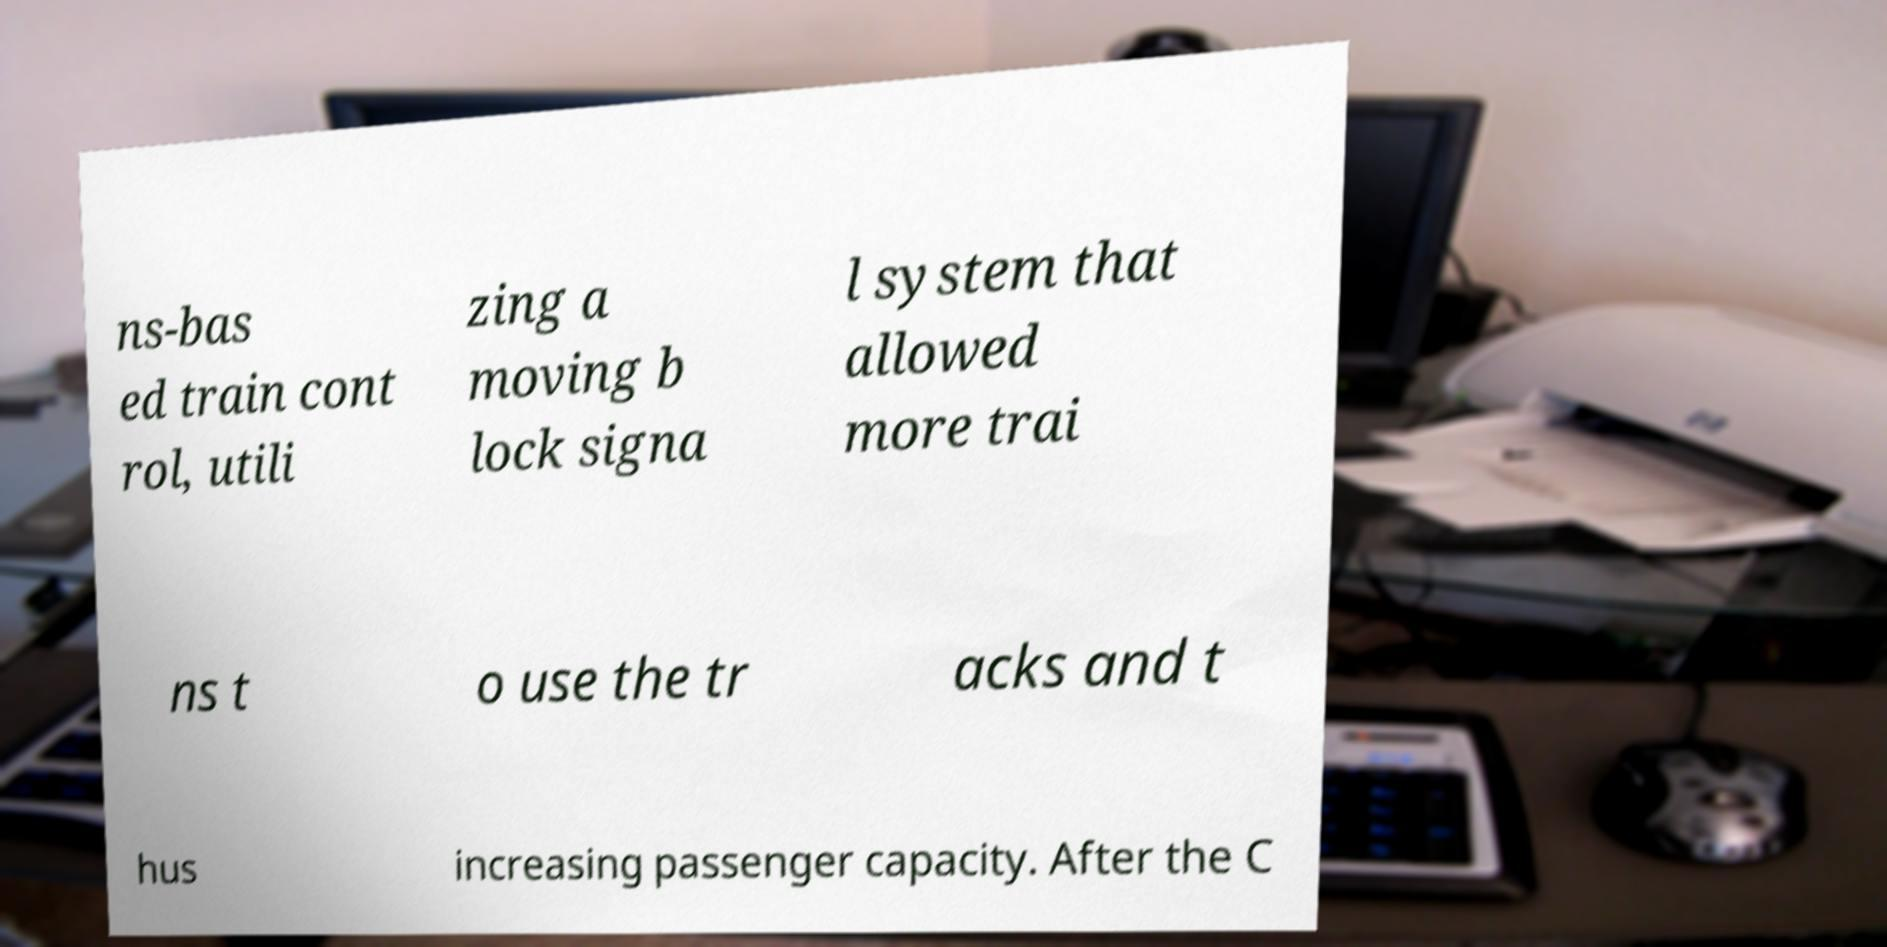Could you extract and type out the text from this image? ns-bas ed train cont rol, utili zing a moving b lock signa l system that allowed more trai ns t o use the tr acks and t hus increasing passenger capacity. After the C 